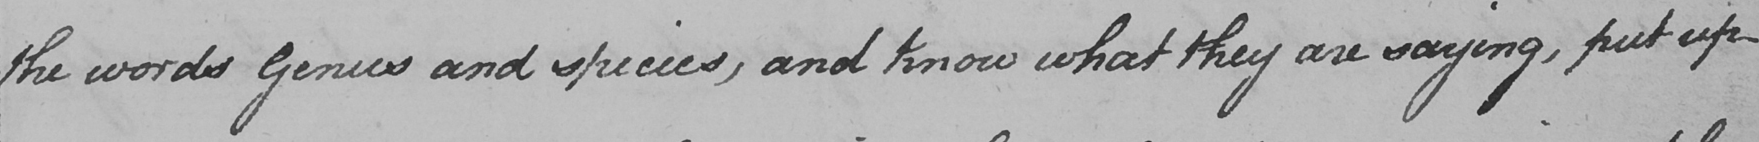What is written in this line of handwriting? the words Genus and species , and know what they are saying , put up 